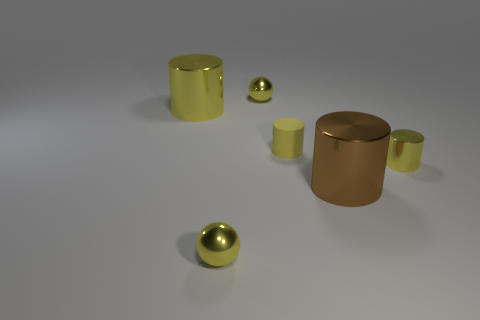Subtract all big brown cylinders. How many cylinders are left? 3 Subtract all yellow cylinders. How many cylinders are left? 1 Subtract all cylinders. How many objects are left? 2 Add 3 metal balls. How many objects exist? 9 Subtract 0 green cubes. How many objects are left? 6 Subtract 2 cylinders. How many cylinders are left? 2 Subtract all yellow cylinders. Subtract all gray spheres. How many cylinders are left? 1 Subtract all purple spheres. How many gray cylinders are left? 0 Subtract all yellow spheres. Subtract all tiny rubber cylinders. How many objects are left? 3 Add 1 yellow spheres. How many yellow spheres are left? 3 